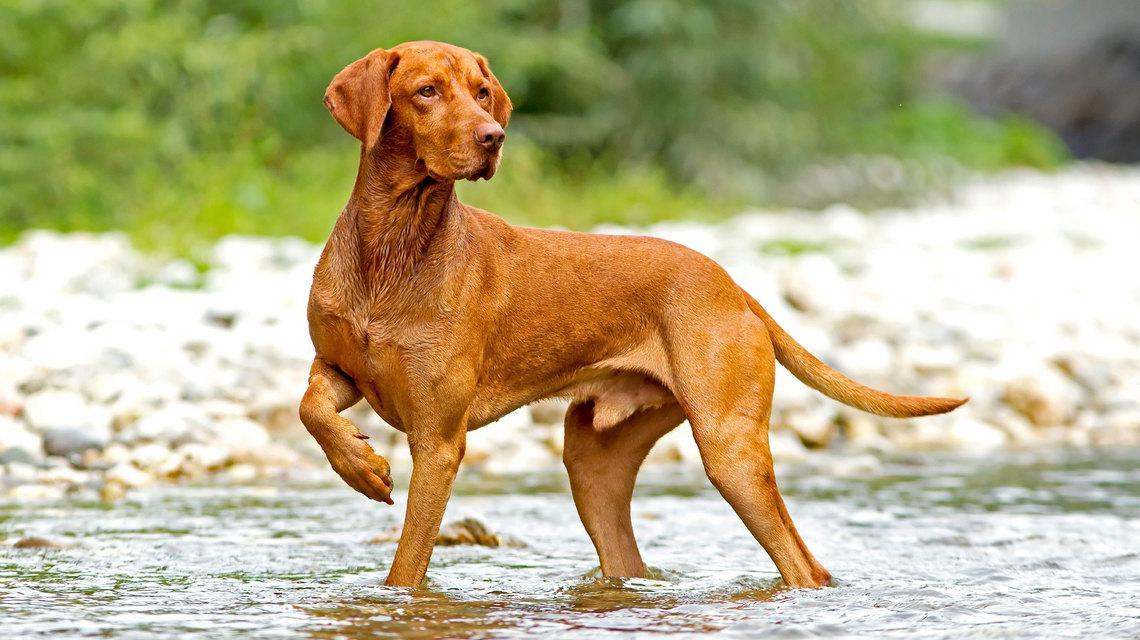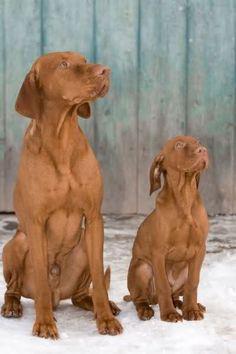The first image is the image on the left, the second image is the image on the right. For the images shown, is this caption "One image shows two dogs with the same coloring sitting side-by-side with their chests facing the camera, and the other image shows one dog in a standing pose outdoors." true? Answer yes or no. Yes. The first image is the image on the left, the second image is the image on the right. Analyze the images presented: Is the assertion "The left image contains exactly two dogs." valid? Answer yes or no. No. 